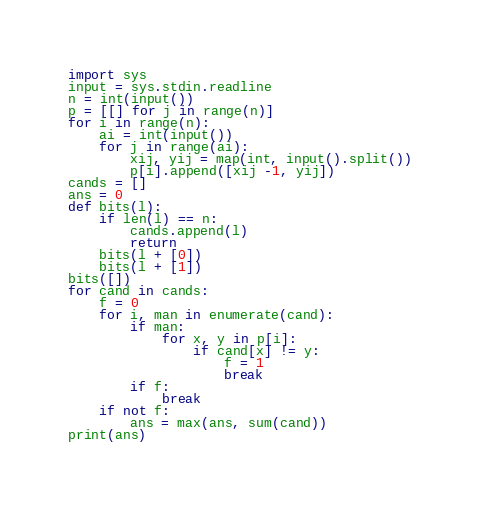Convert code to text. <code><loc_0><loc_0><loc_500><loc_500><_Python_>import sys
input = sys.stdin.readline
n = int(input())
p = [[] for j in range(n)]
for i in range(n):
    ai = int(input())
    for j in range(ai):
        xij, yij = map(int, input().split())
        p[i].append([xij -1, yij])
cands = []
ans = 0
def bits(l):
    if len(l) == n:
        cands.append(l)
        return
    bits(l + [0])
    bits(l + [1])
bits([])
for cand in cands:
    f = 0
    for i, man in enumerate(cand):
        if man:
            for x, y in p[i]:
                if cand[x] != y:
                    f = 1
                    break
        if f:
            break
    if not f:
        ans = max(ans, sum(cand))
print(ans)
</code> 